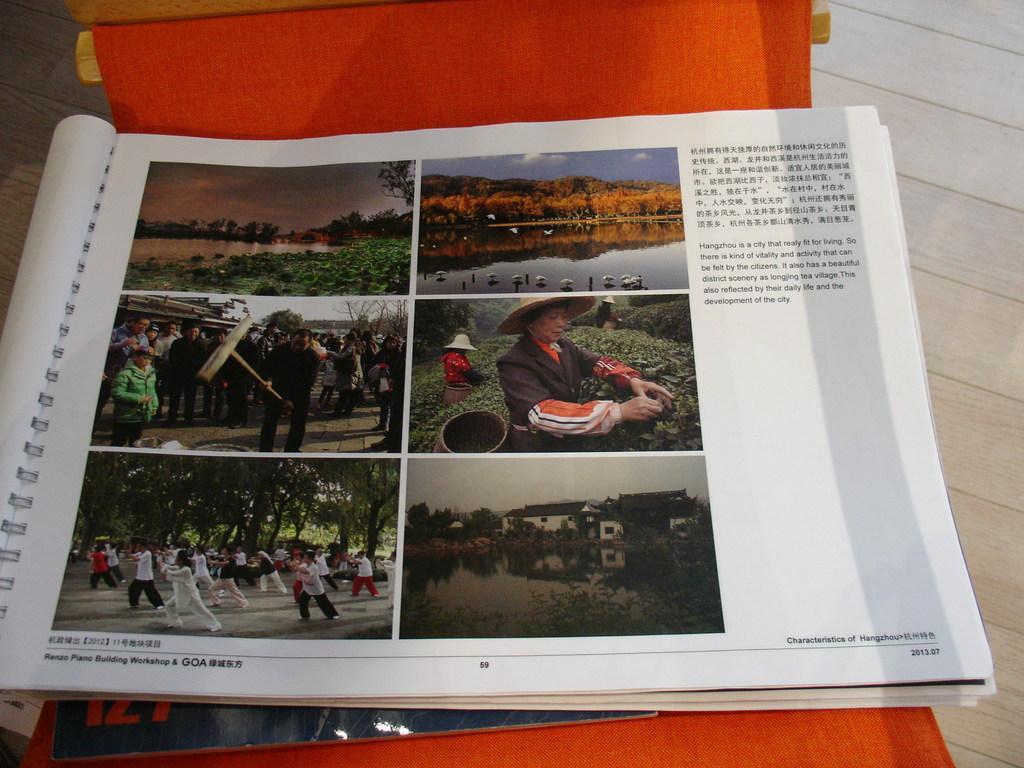How would you summarize this image in a sentence or two? In this image we can see an object which looks like a chair on the floor. And on that chair there is a book with images and text. 